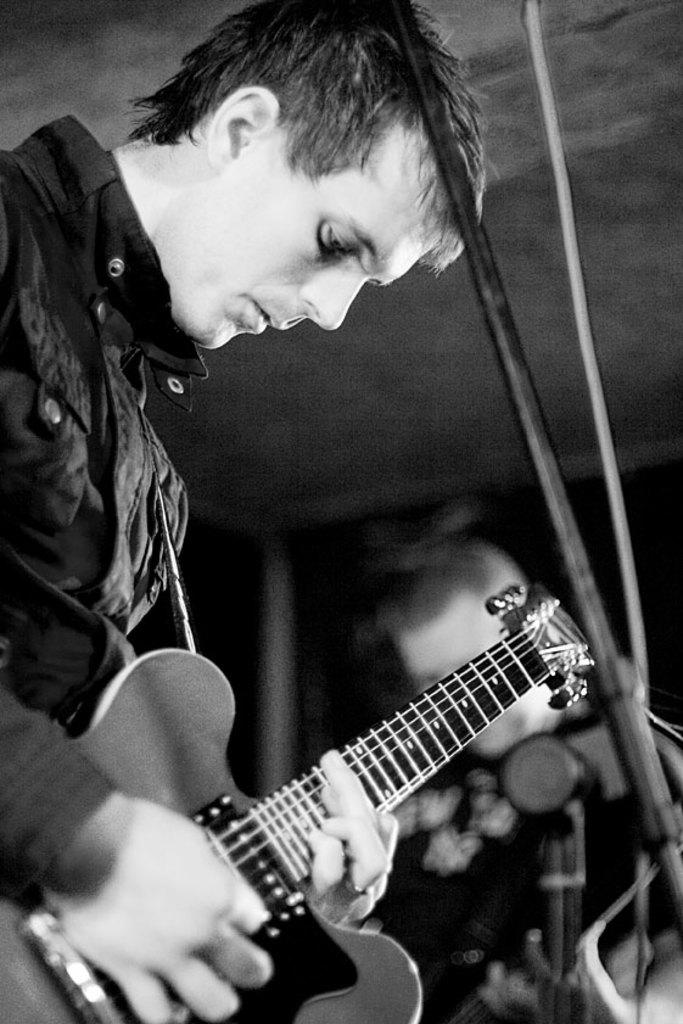How many people are in the image? There are two persons in the image. What are the persons doing in the image? The persons are standing and playing musical instruments. What are the persons wearing in the image? Both persons are wearing black jackets. Can you see a tent in the image? No, there is no tent present in the image. What type of frog is playing the musical instrument in the image? There are no frogs in the image; the persons playing the musical instruments are human. 